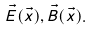<formula> <loc_0><loc_0><loc_500><loc_500>\vec { E } ( \vec { x } ) , \vec { B } ( \vec { x } ) .</formula> 